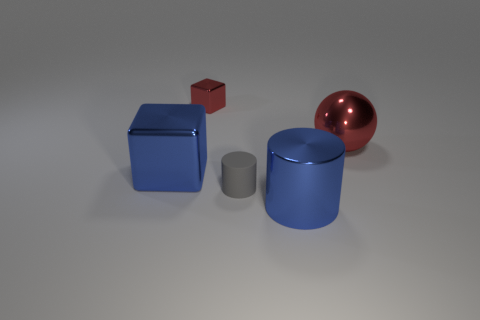Add 2 metallic balls. How many objects exist? 7 Subtract all blocks. How many objects are left? 3 Subtract 0 gray spheres. How many objects are left? 5 Subtract all tiny purple matte objects. Subtract all metal cubes. How many objects are left? 3 Add 4 large blue metallic cubes. How many large blue metallic cubes are left? 5 Add 2 large matte objects. How many large matte objects exist? 2 